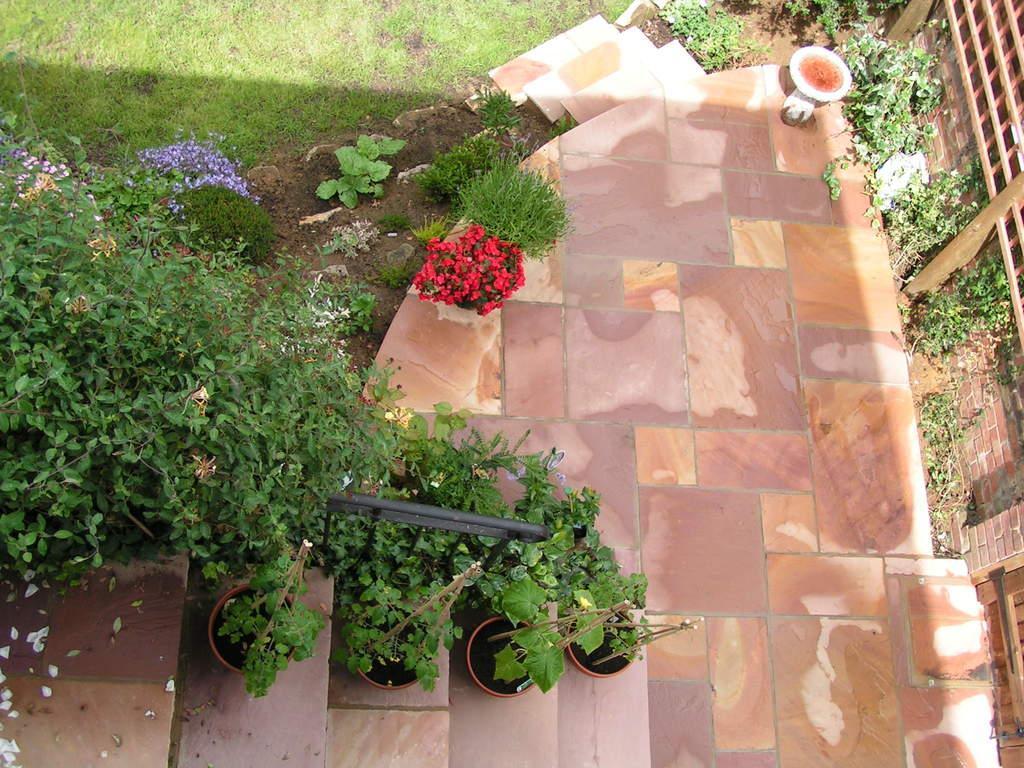Please provide a concise description of this image. In this image we can see plants, staircase. In the background of the image there is grass. There is floor. To the right side of the image there is wall. 